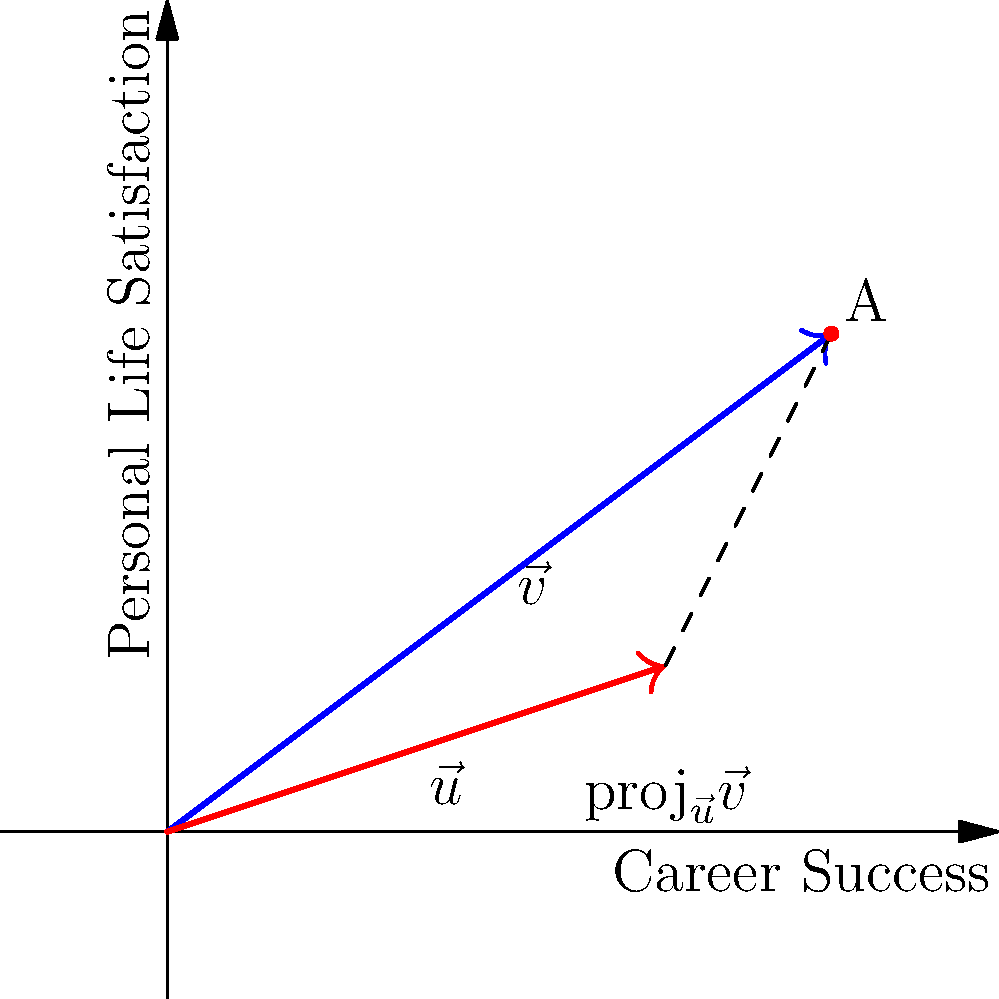Based on the vector diagram representing Harry Burns' career trajectory ($\vec{v}$) and its projection onto his personal life ($\vec{u}$), what is the magnitude of the projection of $\vec{v}$ onto $\vec{u}$? Assume each unit on the axes represents 1 year in career or personal life development. To find the magnitude of the projection of $\vec{v}$ onto $\vec{u}$, we'll follow these steps:

1. Identify the vectors:
   $\vec{v} = (4, 3)$ (Career trajectory)
   $\vec{u} = (3, 1)$ (Personal life vector)

2. Calculate the dot product of $\vec{v}$ and $\vec{u}$:
   $\vec{v} \cdot \vec{u} = (4)(3) + (3)(1) = 12 + 3 = 15$

3. Calculate the magnitude of $\vec{u}$:
   $|\vec{u}| = \sqrt{3^2 + 1^2} = \sqrt{10}$

4. Use the formula for vector projection:
   $\mathrm{proj}_{\vec{u}}\vec{v} = \frac{\vec{v} \cdot \vec{u}}{|\vec{u}|^2} \vec{u}$

5. Calculate the scalar factor:
   $\frac{\vec{v} \cdot \vec{u}}{|\vec{u}|^2} = \frac{15}{10} = \frac{3}{2}$

6. The projection vector is:
   $\mathrm{proj}_{\vec{u}}\vec{v} = \frac{3}{2}(3, 1) = (\frac{9}{2}, \frac{3}{2})$

7. Calculate the magnitude of the projection:
   $|\mathrm{proj}_{\vec{u}}\vec{v}| = \sqrt{(\frac{9}{2})^2 + (\frac{3}{2})^2} = \sqrt{\frac{81}{4} + \frac{9}{4}} = \sqrt{\frac{90}{4}} = \frac{3\sqrt{10}}{2}$

Therefore, the magnitude of the projection of Harry's career trajectory onto his personal life is $\frac{3\sqrt{10}}{2}$ years.
Answer: $\frac{3\sqrt{10}}{2}$ years 